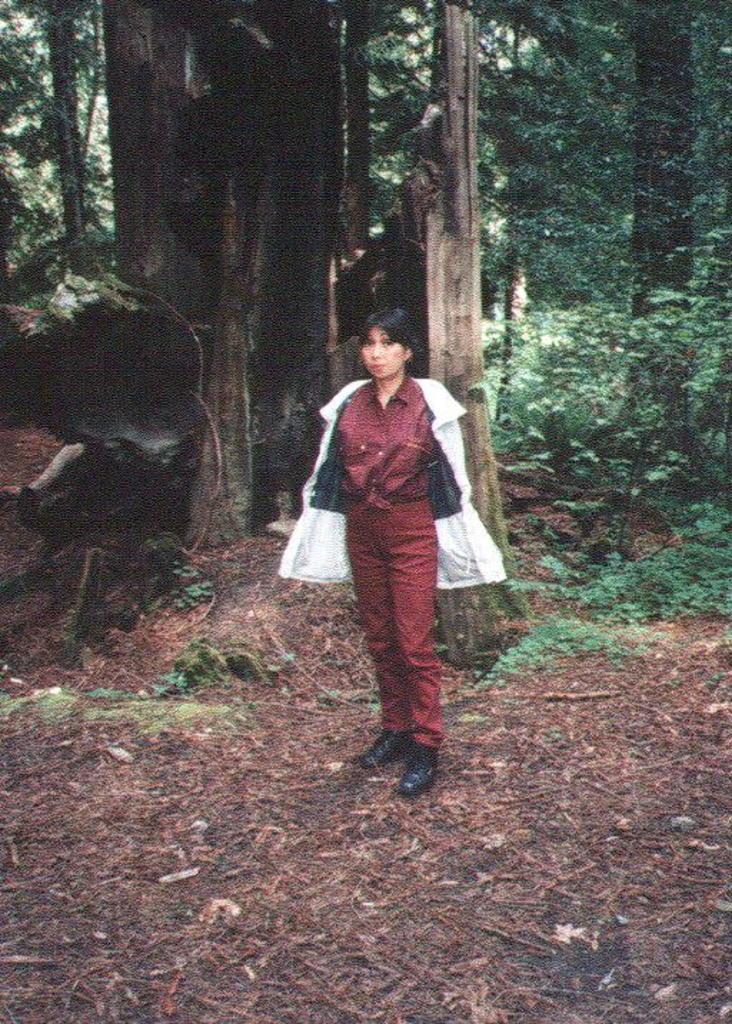Could you give a brief overview of what you see in this image? In this image we can see a woman is standing on the ground. In the background we can see trees and plants. 